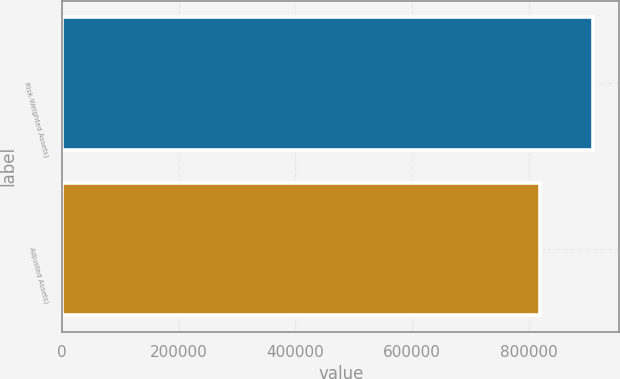<chart> <loc_0><loc_0><loc_500><loc_500><bar_chart><fcel>Risk-Weighted Assets)<fcel>Adjusted Assets)<nl><fcel>909959<fcel>819747<nl></chart> 